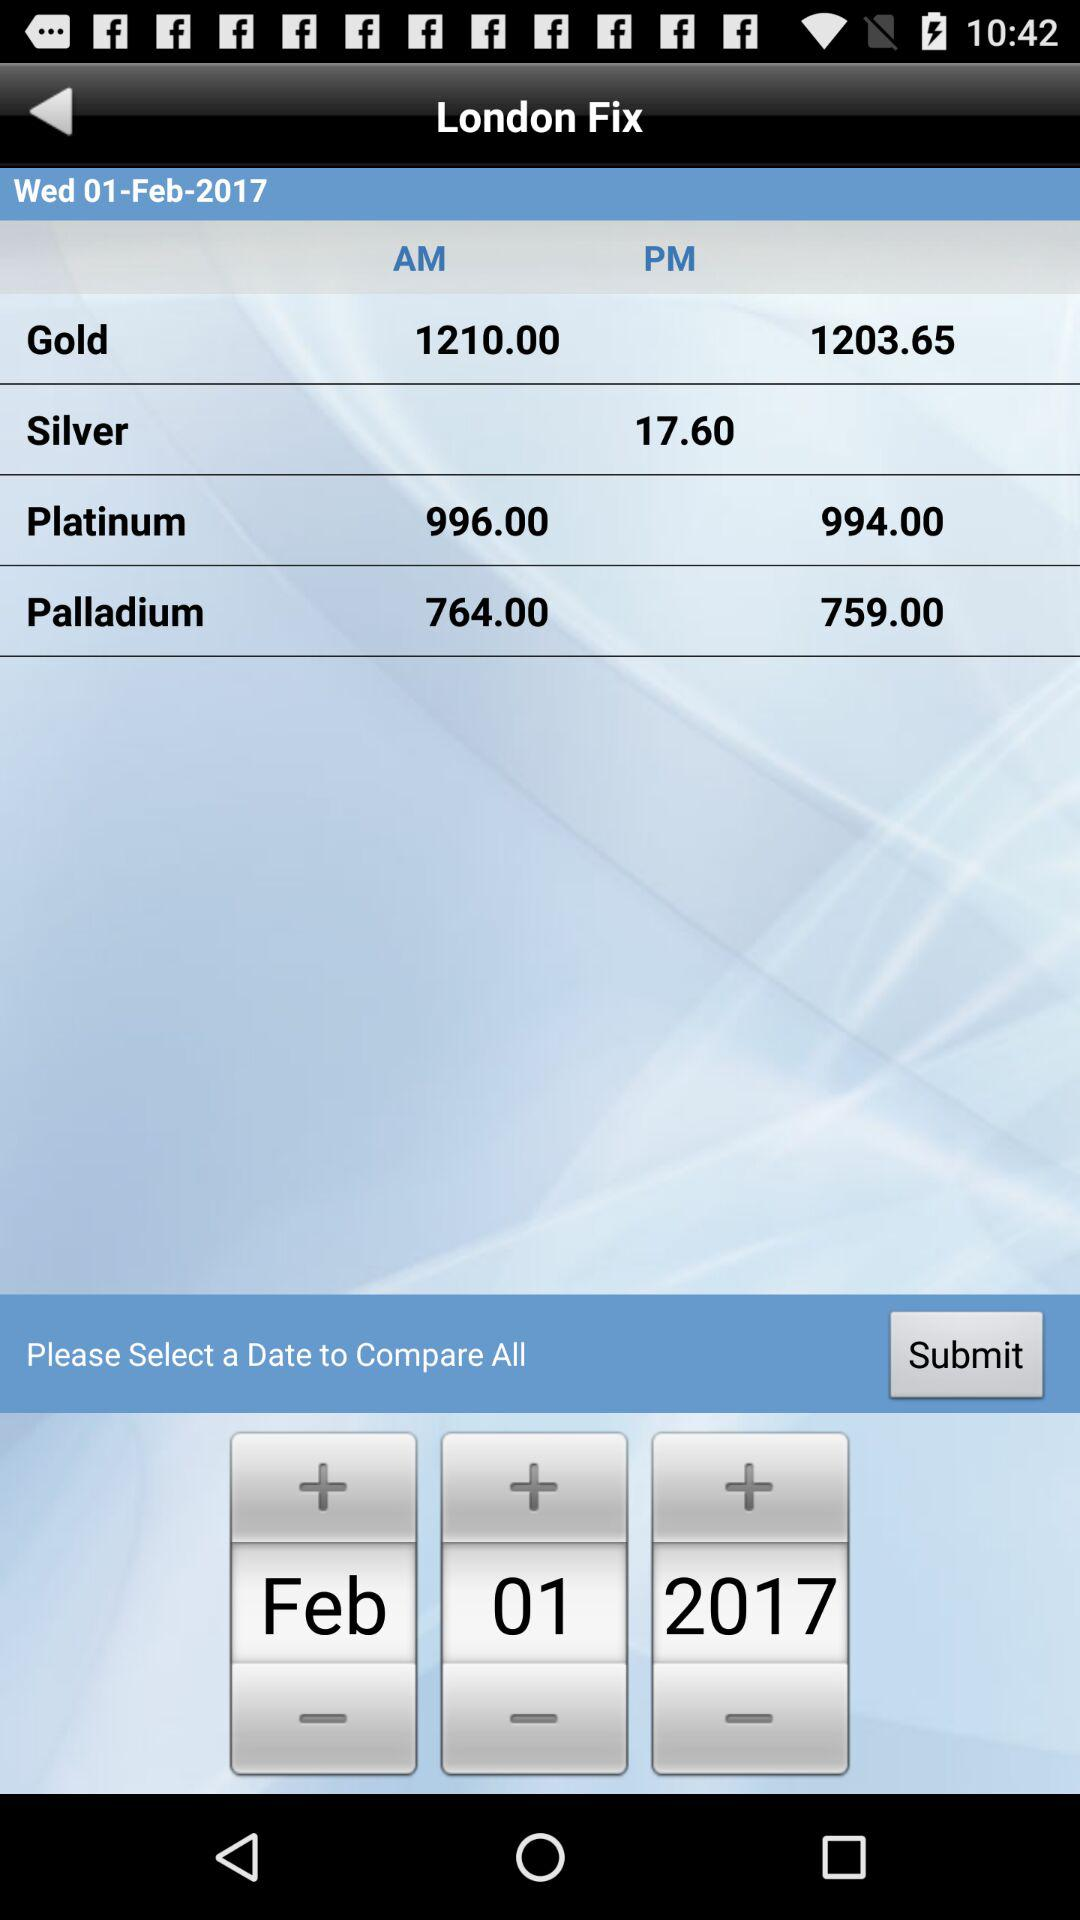Which material has a price of 17.60? The material that has a price of 17.60 is silver. 